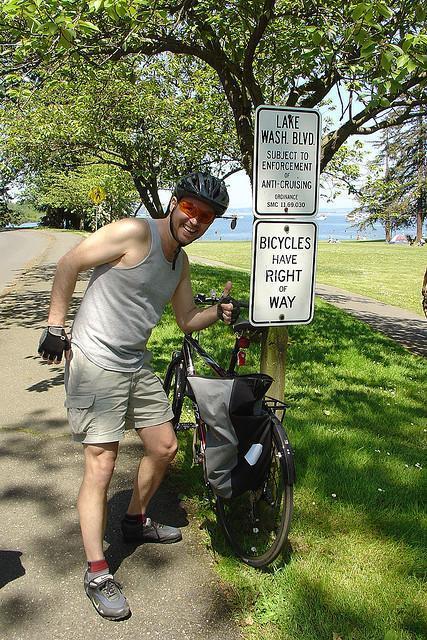How many sandwiches do you see?
Give a very brief answer. 0. 